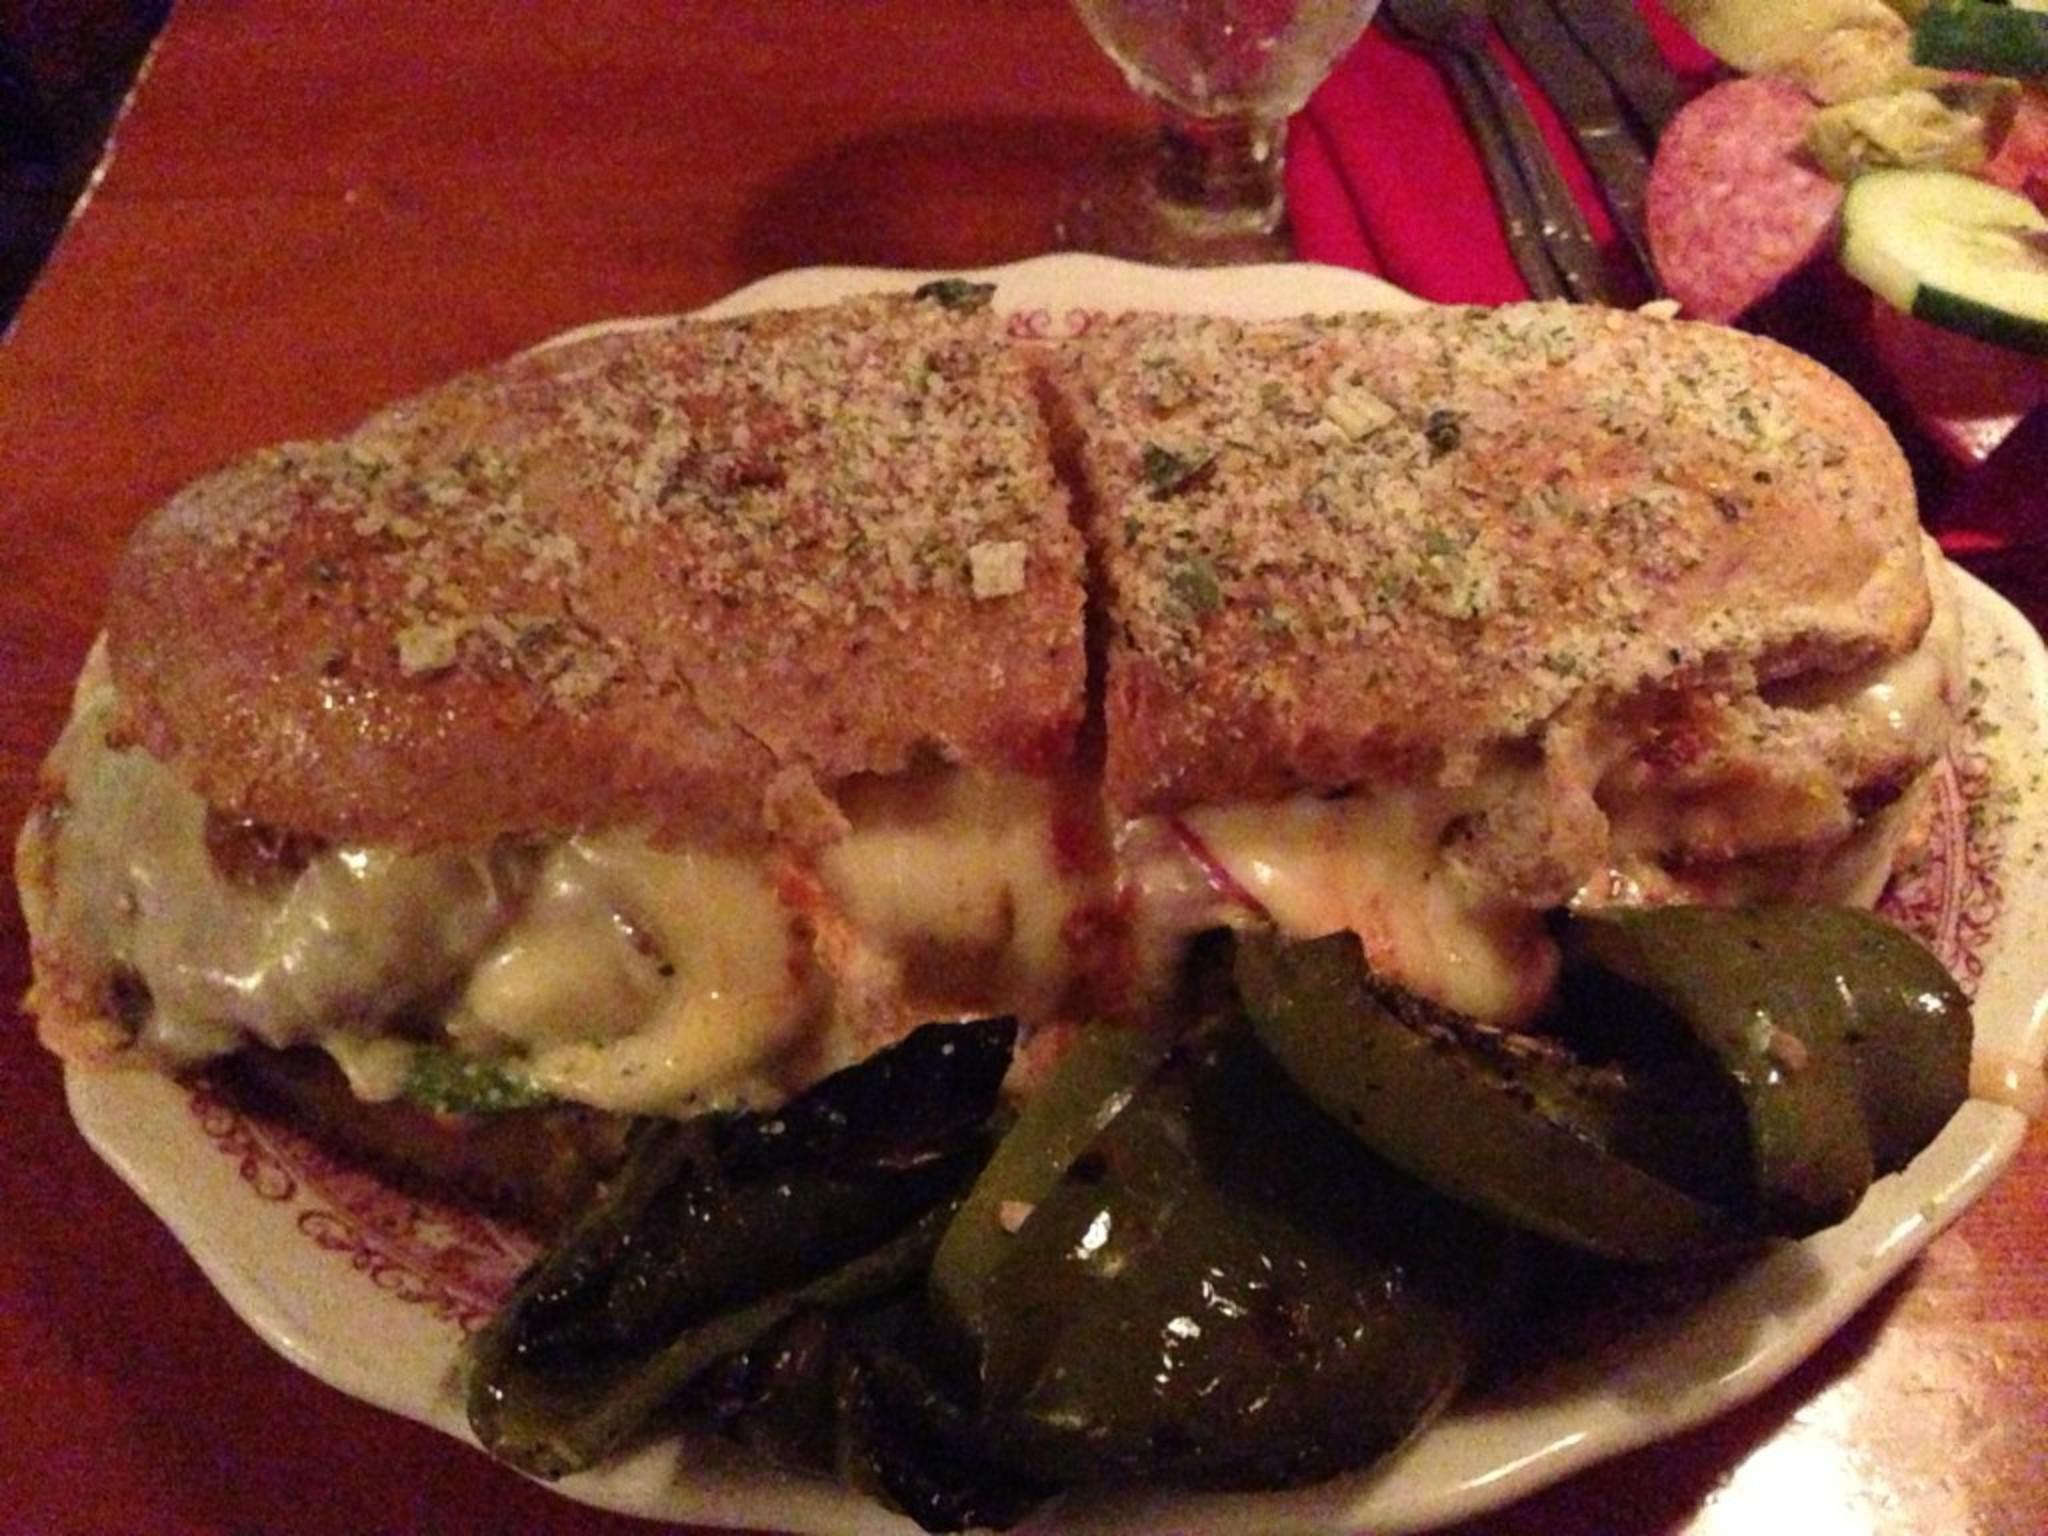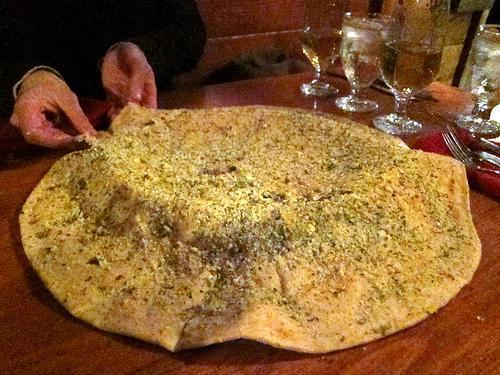The first image is the image on the left, the second image is the image on the right. For the images shown, is this caption "Each image shows exactly one item with melted cheese surrounded by a round crust on a plate with ornate dark red trim." true? Answer yes or no. No. The first image is the image on the left, the second image is the image on the right. For the images displayed, is the sentence "Both images show soup in a bread bowl." factually correct? Answer yes or no. No. 